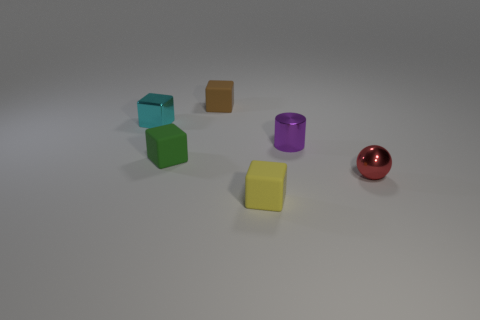Are there fewer small cubes than blue objects?
Your answer should be compact. No. There is a small cyan thing that is to the left of the block that is behind the object that is on the left side of the green object; what is it made of?
Provide a short and direct response. Metal. Is the block that is left of the green thing made of the same material as the small red object in front of the tiny green matte block?
Make the answer very short. Yes. What material is the yellow block that is the same size as the brown rubber block?
Keep it short and to the point. Rubber. What number of blocks are to the left of the tiny rubber object on the right side of the matte thing that is behind the small cyan shiny cube?
Your answer should be very brief. 3. There is a metallic object that is both to the right of the green thing and behind the green matte object; what color is it?
Offer a very short reply. Purple. How many red metallic balls are the same size as the brown block?
Provide a short and direct response. 1. What shape is the tiny purple thing right of the matte cube behind the small purple metal cylinder?
Make the answer very short. Cylinder. What is the shape of the tiny red metal object in front of the small metallic object to the left of the tiny rubber thing to the right of the tiny brown matte object?
Your answer should be very brief. Sphere. How many other rubber objects are the same shape as the tiny cyan thing?
Offer a terse response. 3. 